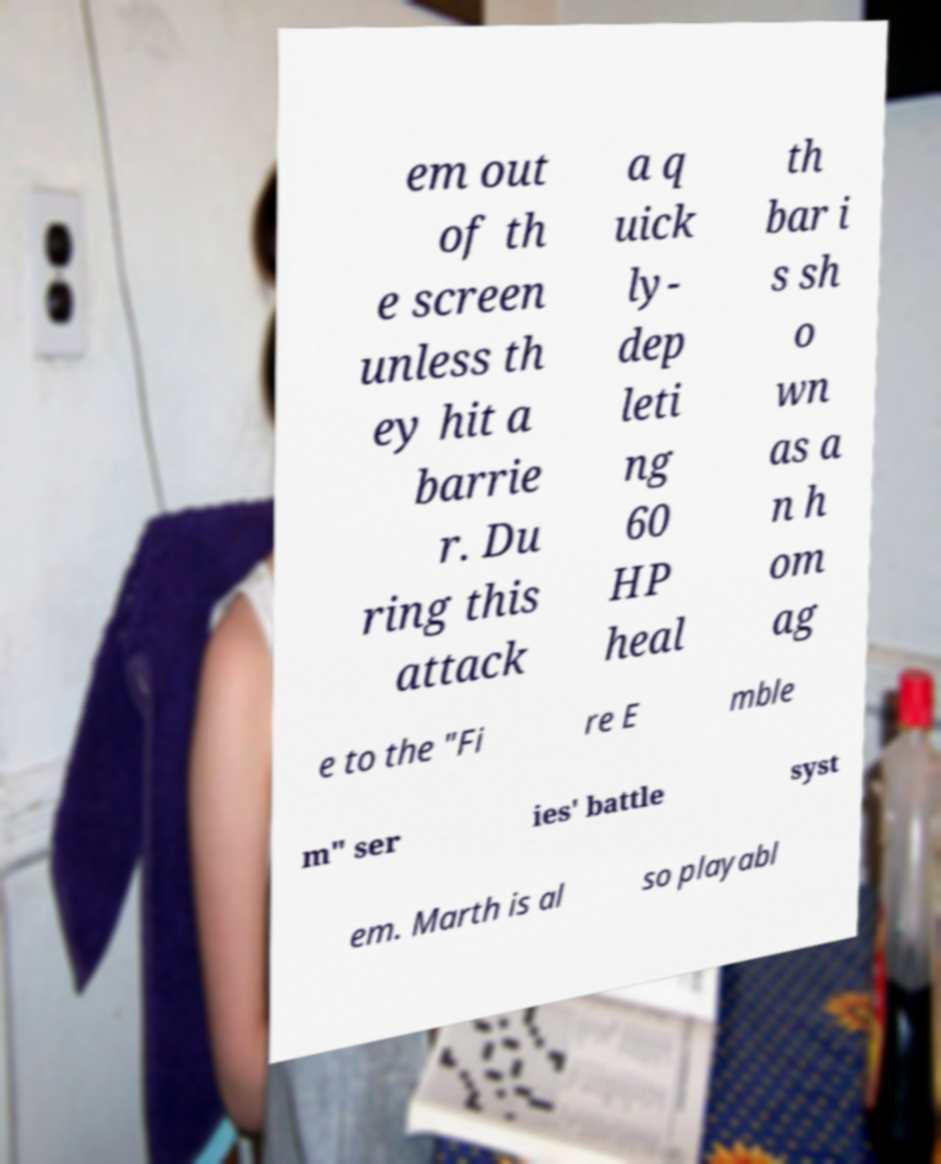There's text embedded in this image that I need extracted. Can you transcribe it verbatim? em out of th e screen unless th ey hit a barrie r. Du ring this attack a q uick ly- dep leti ng 60 HP heal th bar i s sh o wn as a n h om ag e to the "Fi re E mble m" ser ies' battle syst em. Marth is al so playabl 